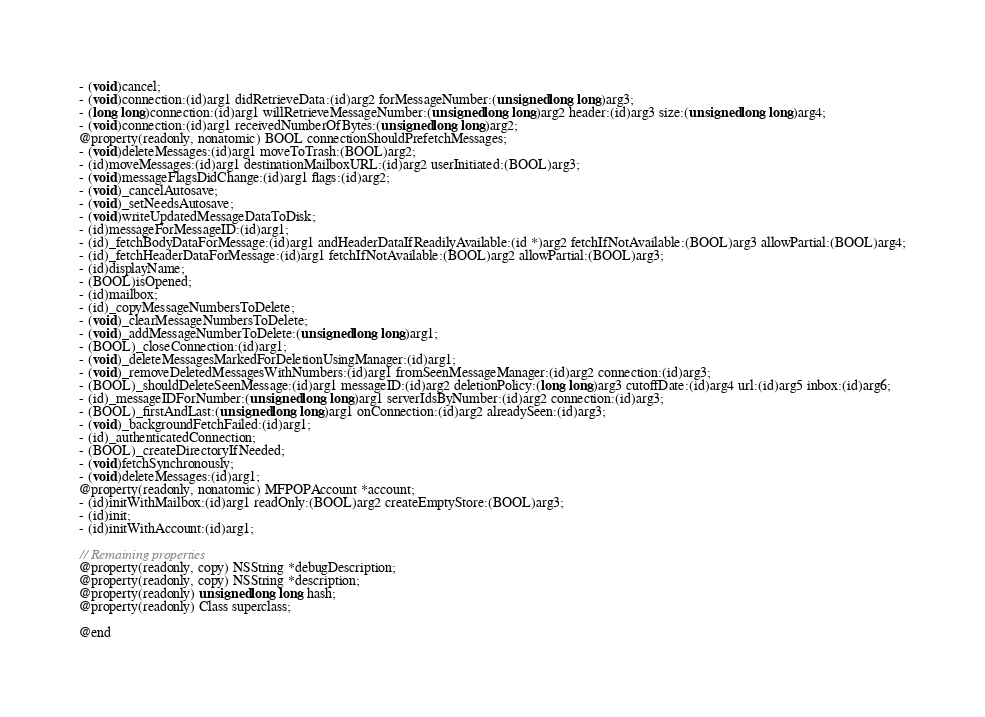<code> <loc_0><loc_0><loc_500><loc_500><_C_>- (void)cancel;
- (void)connection:(id)arg1 didRetrieveData:(id)arg2 forMessageNumber:(unsigned long long)arg3;
- (long long)connection:(id)arg1 willRetrieveMessageNumber:(unsigned long long)arg2 header:(id)arg3 size:(unsigned long long)arg4;
- (void)connection:(id)arg1 receivedNumberOfBytes:(unsigned long long)arg2;
@property(readonly, nonatomic) BOOL connectionShouldPrefetchMessages;
- (void)deleteMessages:(id)arg1 moveToTrash:(BOOL)arg2;
- (id)moveMessages:(id)arg1 destinationMailboxURL:(id)arg2 userInitiated:(BOOL)arg3;
- (void)messageFlagsDidChange:(id)arg1 flags:(id)arg2;
- (void)_cancelAutosave;
- (void)_setNeedsAutosave;
- (void)writeUpdatedMessageDataToDisk;
- (id)messageForMessageID:(id)arg1;
- (id)_fetchBodyDataForMessage:(id)arg1 andHeaderDataIfReadilyAvailable:(id *)arg2 fetchIfNotAvailable:(BOOL)arg3 allowPartial:(BOOL)arg4;
- (id)_fetchHeaderDataForMessage:(id)arg1 fetchIfNotAvailable:(BOOL)arg2 allowPartial:(BOOL)arg3;
- (id)displayName;
- (BOOL)isOpened;
- (id)mailbox;
- (id)_copyMessageNumbersToDelete;
- (void)_clearMessageNumbersToDelete;
- (void)_addMessageNumberToDelete:(unsigned long long)arg1;
- (BOOL)_closeConnection:(id)arg1;
- (void)_deleteMessagesMarkedForDeletionUsingManager:(id)arg1;
- (void)_removeDeletedMessagesWithNumbers:(id)arg1 fromSeenMessageManager:(id)arg2 connection:(id)arg3;
- (BOOL)_shouldDeleteSeenMessage:(id)arg1 messageID:(id)arg2 deletionPolicy:(long long)arg3 cutoffDate:(id)arg4 url:(id)arg5 inbox:(id)arg6;
- (id)_messageIDForNumber:(unsigned long long)arg1 serverIdsByNumber:(id)arg2 connection:(id)arg3;
- (BOOL)_firstAndLast:(unsigned long long)arg1 onConnection:(id)arg2 alreadySeen:(id)arg3;
- (void)_backgroundFetchFailed:(id)arg1;
- (id)_authenticatedConnection;
- (BOOL)_createDirectoryIfNeeded;
- (void)fetchSynchronously;
- (void)deleteMessages:(id)arg1;
@property(readonly, nonatomic) MFPOPAccount *account;
- (id)initWithMailbox:(id)arg1 readOnly:(BOOL)arg2 createEmptyStore:(BOOL)arg3;
- (id)init;
- (id)initWithAccount:(id)arg1;

// Remaining properties
@property(readonly, copy) NSString *debugDescription;
@property(readonly, copy) NSString *description;
@property(readonly) unsigned long long hash;
@property(readonly) Class superclass;

@end

</code> 